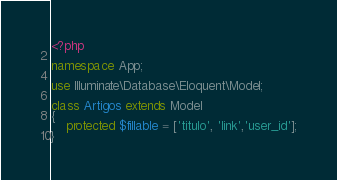Convert code to text. <code><loc_0><loc_0><loc_500><loc_500><_PHP_><?php

namespace App;

use Illuminate\Database\Eloquent\Model;

class Artigos extends Model
{
    protected $fillable = ['titulo', 'link','user_id'];
}
</code> 